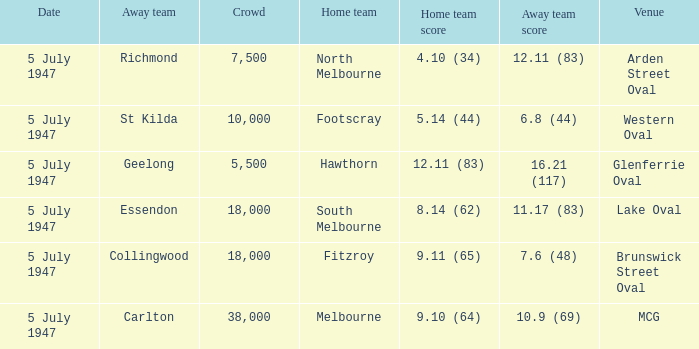What away team played against Footscray as the home team? St Kilda. 